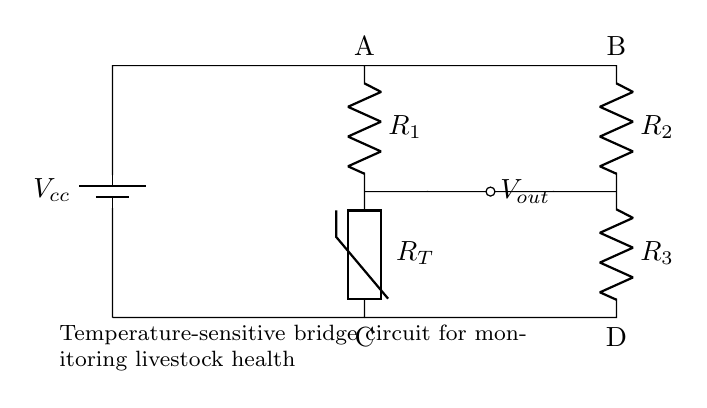What type of circuit is shown here? The circuit is a bridge circuit, specifically designed to monitor temperature changes, indicated by the thermistor component present.
Answer: bridge circuit How many resistors are present in the circuit? The circuit has three resistors: R1, R2, and R3, which are clearly labeled next to their respective symbols.
Answer: three What is the purpose of the thermistor in this circuit? The thermistor is a temperature-sensitive resistor that changes its resistance with temperature, allowing the circuit to measure temperature changes and thus monitor livestock health.
Answer: temperature measurement What is the output voltage labeled as? The output voltage is labeled as Vout, which indicates where the voltage can be measured for monitoring purposes.
Answer: Vout What does R1 represent? R1 is one of the resistors in the circuit, which is used in conjunction with the thermistor to form the temperature-sensitive bridge.
Answer: resistor How are the points A and B connected? Points A and B are connected by a wire that carries the battery voltage to the top of the resistors in the bridge circuit configuration.
Answer: wire What would happen to Vout if the temperature increases? If the temperature increases, the resistance of the thermistor (R_T) decreases, causing a change in the voltage at Vout based on the bridge balance principle.
Answer: Vout decreases 